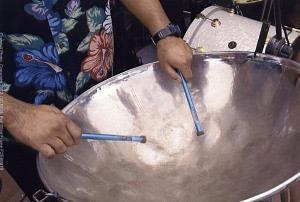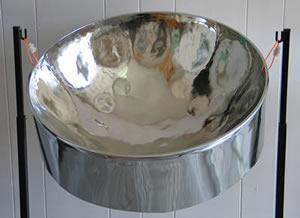The first image is the image on the left, the second image is the image on the right. Analyze the images presented: Is the assertion "There is a total of three drums." valid? Answer yes or no. No. The first image is the image on the left, the second image is the image on the right. Examine the images to the left and right. Is the description "Two hands belonging to someone wearing a hawaiaan shirt are holding drumsticks over the concave bowl of a steel drum in one image, and the other image shows the bowl of at least one drum with no drumsticks in it." accurate? Answer yes or no. Yes. 